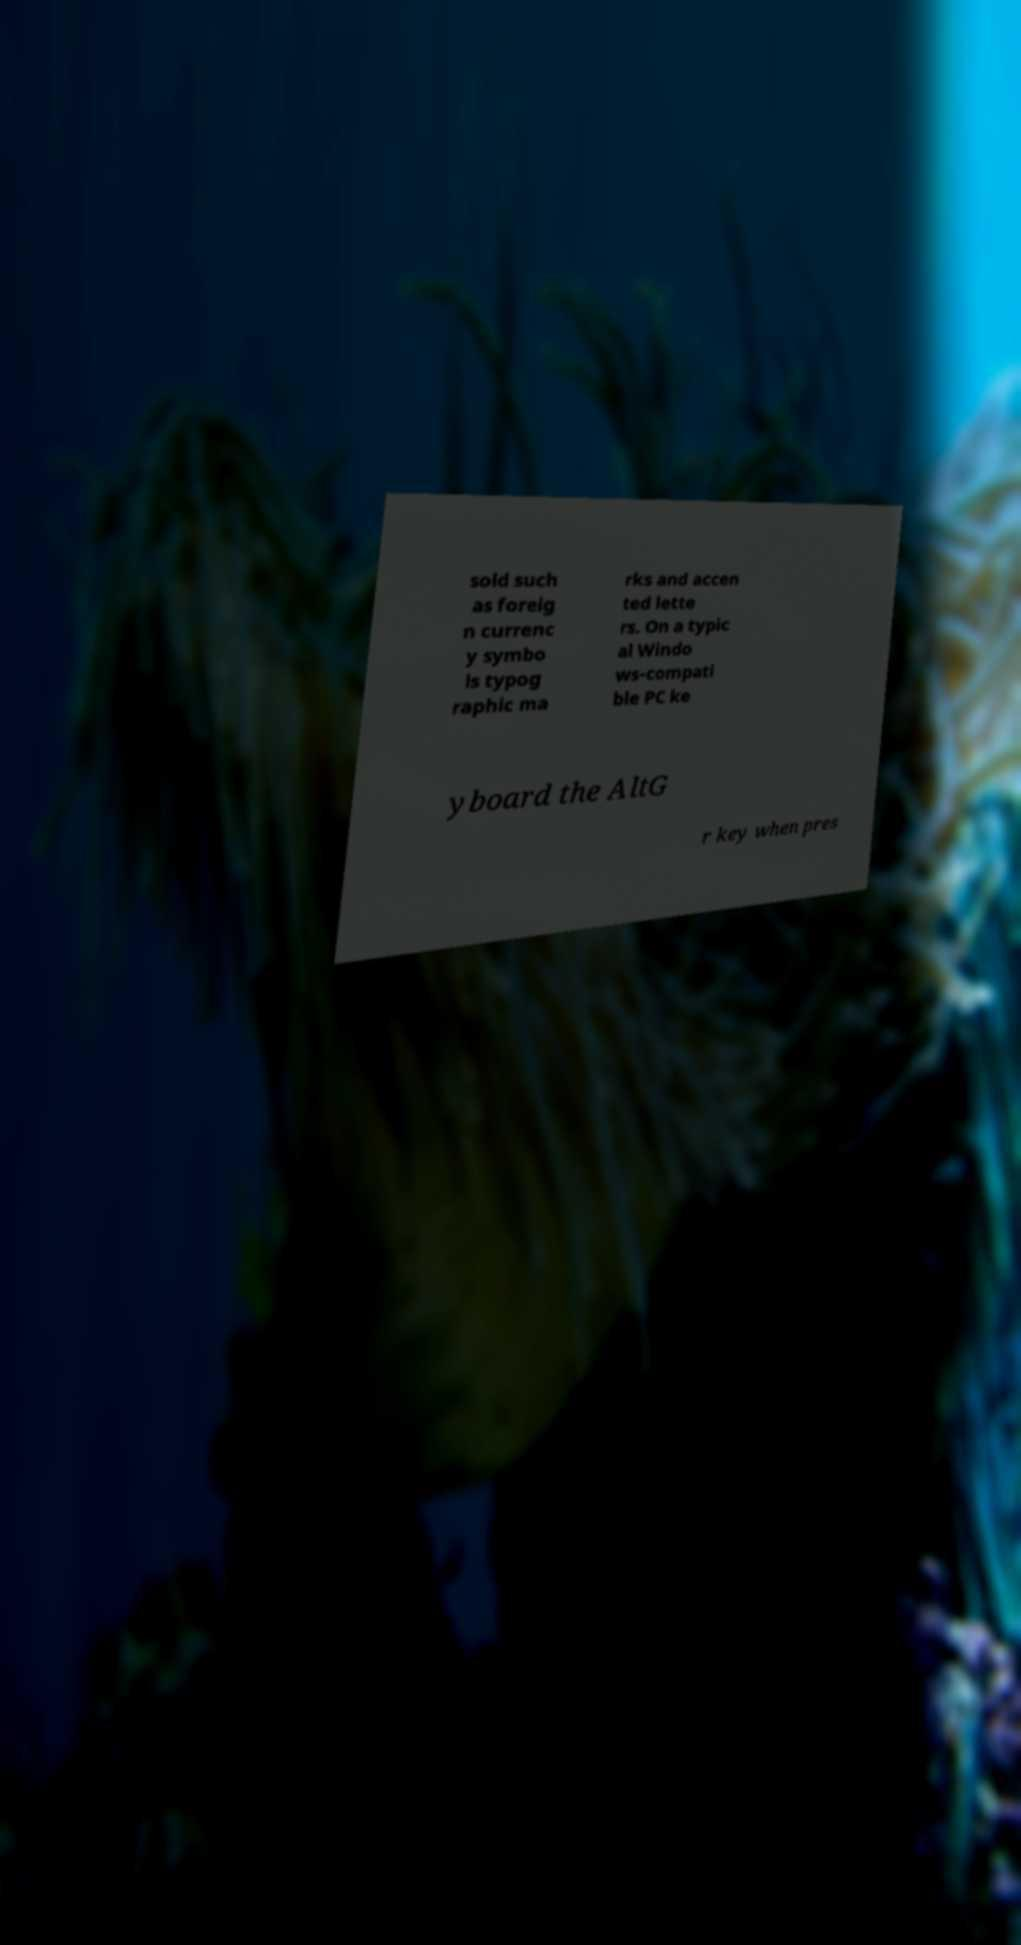There's text embedded in this image that I need extracted. Can you transcribe it verbatim? sold such as foreig n currenc y symbo ls typog raphic ma rks and accen ted lette rs. On a typic al Windo ws-compati ble PC ke yboard the AltG r key when pres 